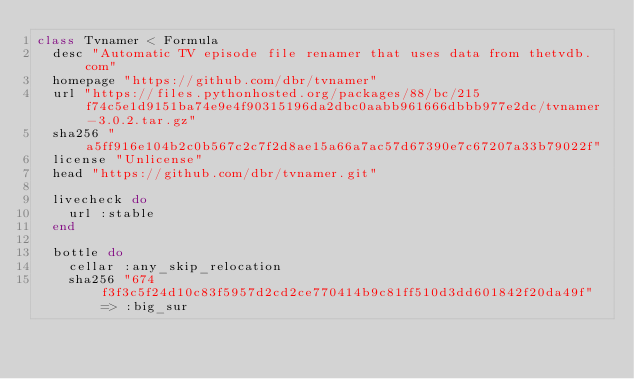<code> <loc_0><loc_0><loc_500><loc_500><_Ruby_>class Tvnamer < Formula
  desc "Automatic TV episode file renamer that uses data from thetvdb.com"
  homepage "https://github.com/dbr/tvnamer"
  url "https://files.pythonhosted.org/packages/88/bc/215f74c5e1d9151ba74e9e4f90315196da2dbc0aabb961666dbbb977e2dc/tvnamer-3.0.2.tar.gz"
  sha256 "a5ff916e104b2c0b567c2c7f2d8ae15a66a7ac57d67390e7c67207a33b79022f"
  license "Unlicense"
  head "https://github.com/dbr/tvnamer.git"

  livecheck do
    url :stable
  end

  bottle do
    cellar :any_skip_relocation
    sha256 "674f3f3c5f24d10c83f5957d2cd2ce770414b9c81ff510d3dd601842f20da49f" => :big_sur</code> 